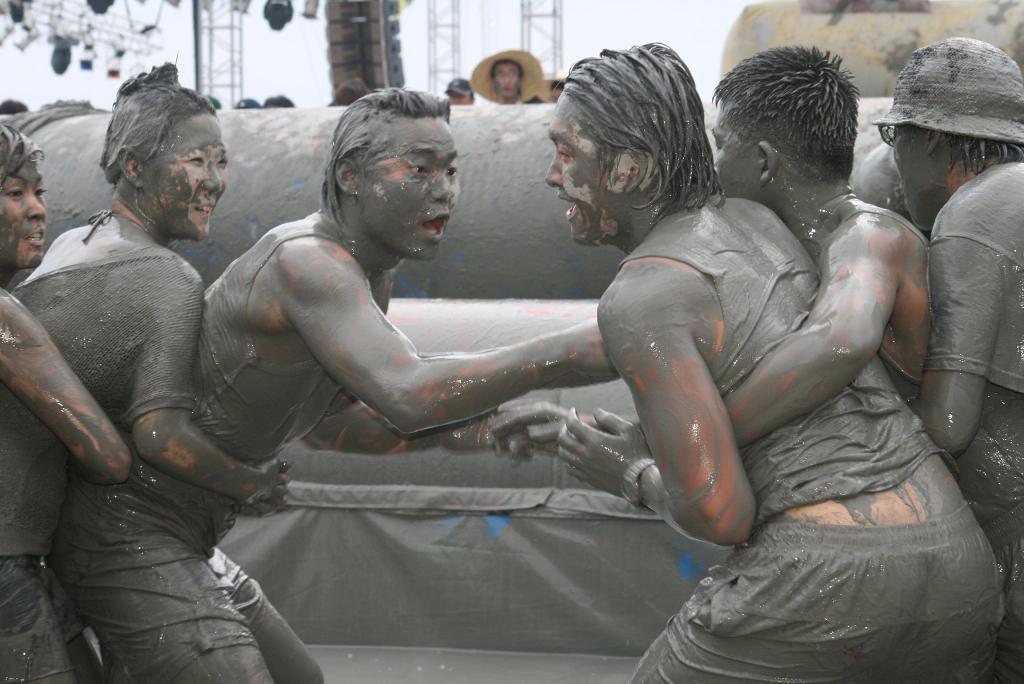Please provide a concise description of this image. In this image I can see group of people. In the background I can see few objects in gray color, few poles, lights and the sky is in white color. 